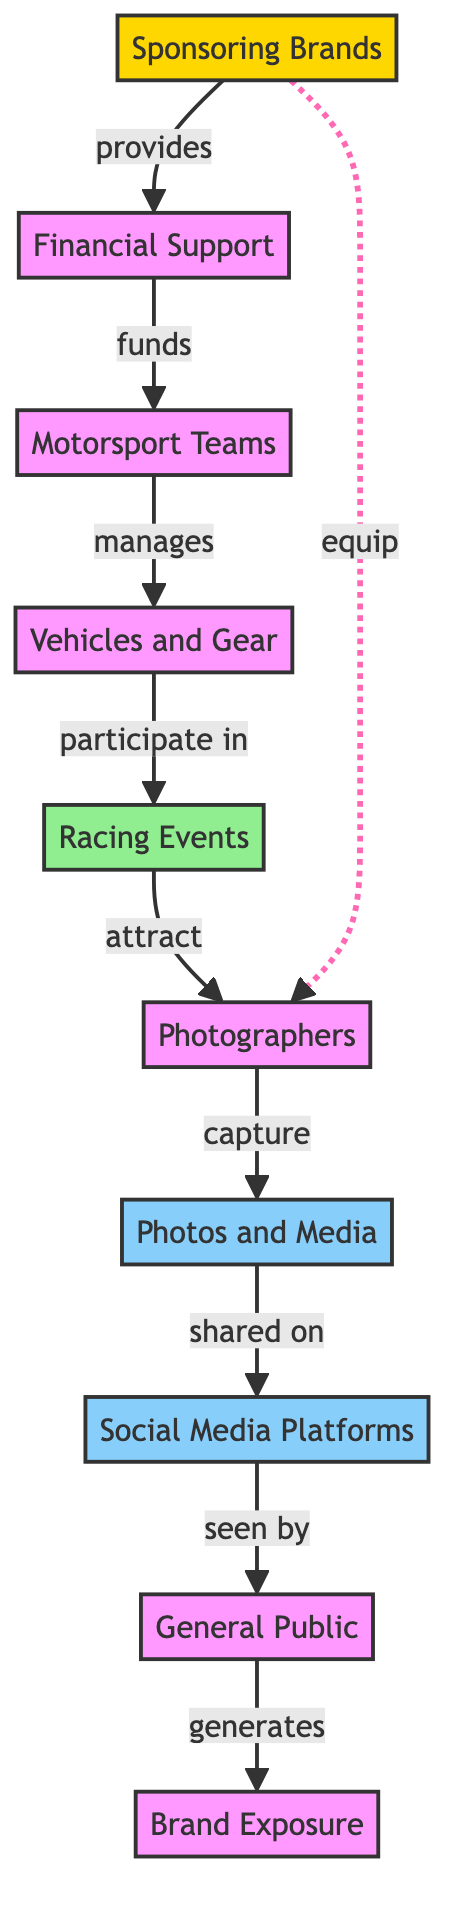What is the first node in the diagram? The first node is "Sponsoring Brands," which represents the starting point of the flow in the diagram, indicating where the process begins.
Answer: Sponsoring Brands How many nodes are in the diagram? By counting the distinct elements represented in the diagram, we find there are a total of 8 nodes: Sponsors, Financial Support, Teams, Vehicles, Events, Photographers, Photos, and Social Media.
Answer: 8 What relationship do Sponsors and Financial Support have? Sponsors provide Financial Support, which indicates a direct contribution or funding relationship from the sponsors to support the activities in motorsports.
Answer: provides Which node does the Financial Support lead to? Financial Support directly funds the Teams, indicating that the financial resources are aimed at supporting racing teams in their operations.
Answer: Teams How does the general Public interact with Social Media? The Public sees Photos shared on Social Media, showing an interaction where the audience views the content that is distributed via social platforms.
Answer: seen by What is the output of the entire flow process? The entire flow process culminates in Brand Exposure, which summarizes the outcome of the interactions and activities in the motorsport ecosystem as it relates to marketing effectiveness.
Answer: Brand Exposure Which node comes after Events in the flow? After Events, the next node in the flow is Photographers, indicating that events are critical points attracting photographers to capture moments.
Answer: Photographers What does the arrow from Sponsors to Photographers signify? The dotted line from Sponsors to Photographers signifies that sponsors equip photographers, which indicates support that enhances the photographers’ ability to capture content.
Answer: equip How do Photos ultimately influence Brand Exposure? Photos, when shared on Social Media, are seen by the Public, which then generates Brand Exposure, showing a clear chain from content creation to audience engagement leading to brand visibility.
Answer: generates 